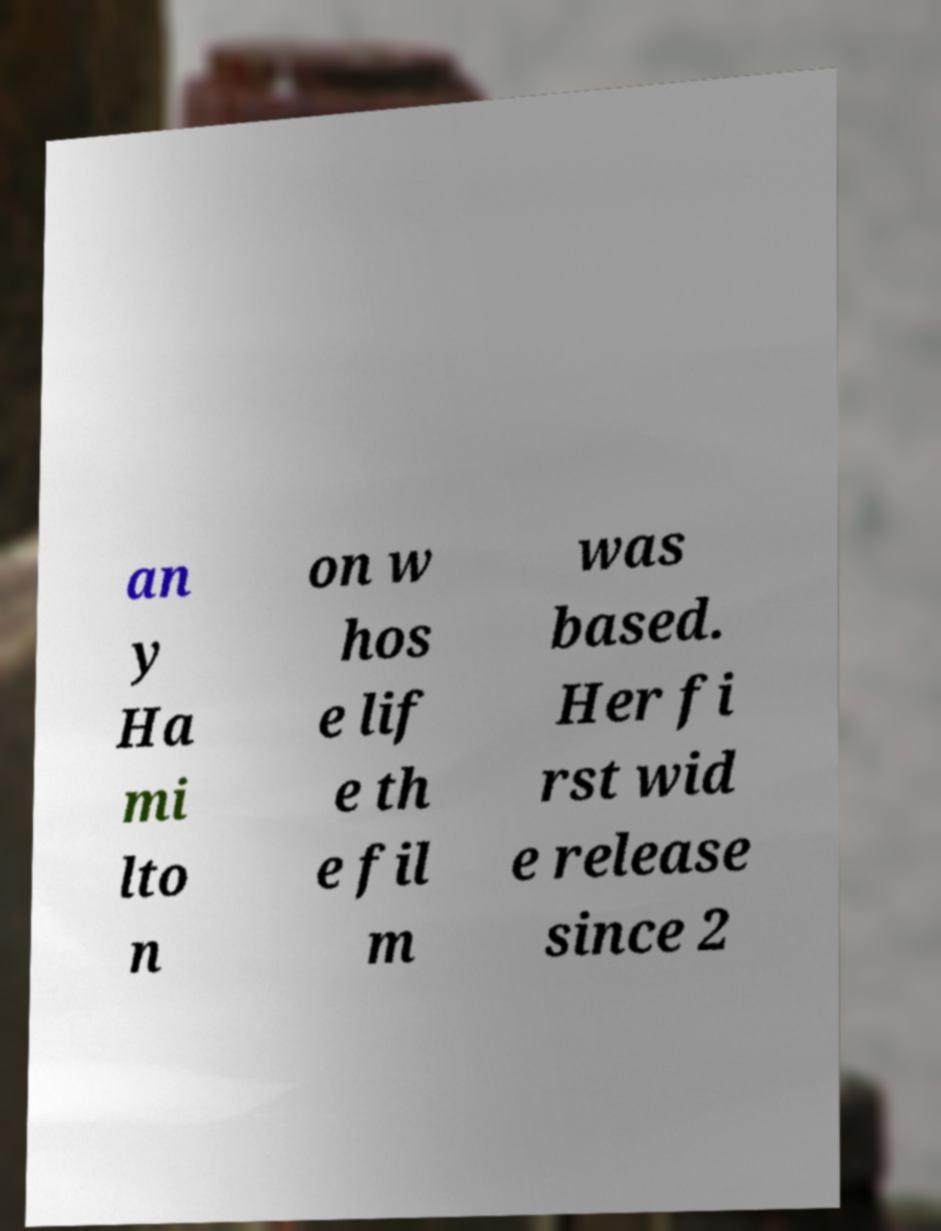What messages or text are displayed in this image? I need them in a readable, typed format. an y Ha mi lto n on w hos e lif e th e fil m was based. Her fi rst wid e release since 2 